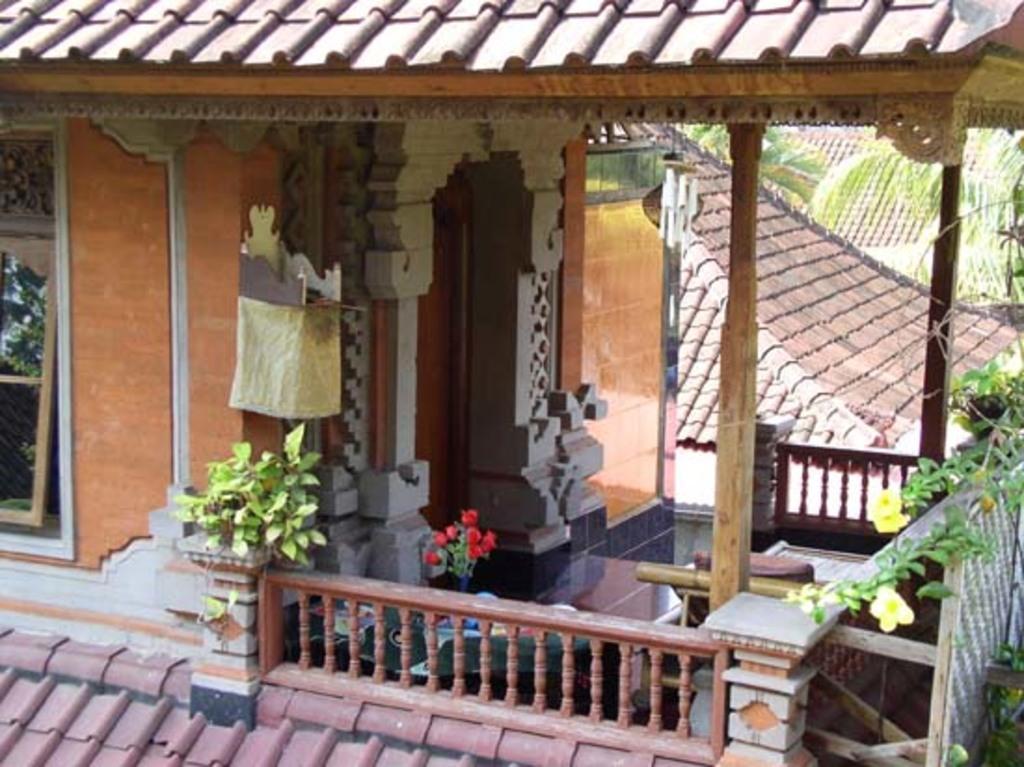Can you describe this image briefly? In this image we can see some houses with roof and windows. We can also see a tree and some plants with flowers. 